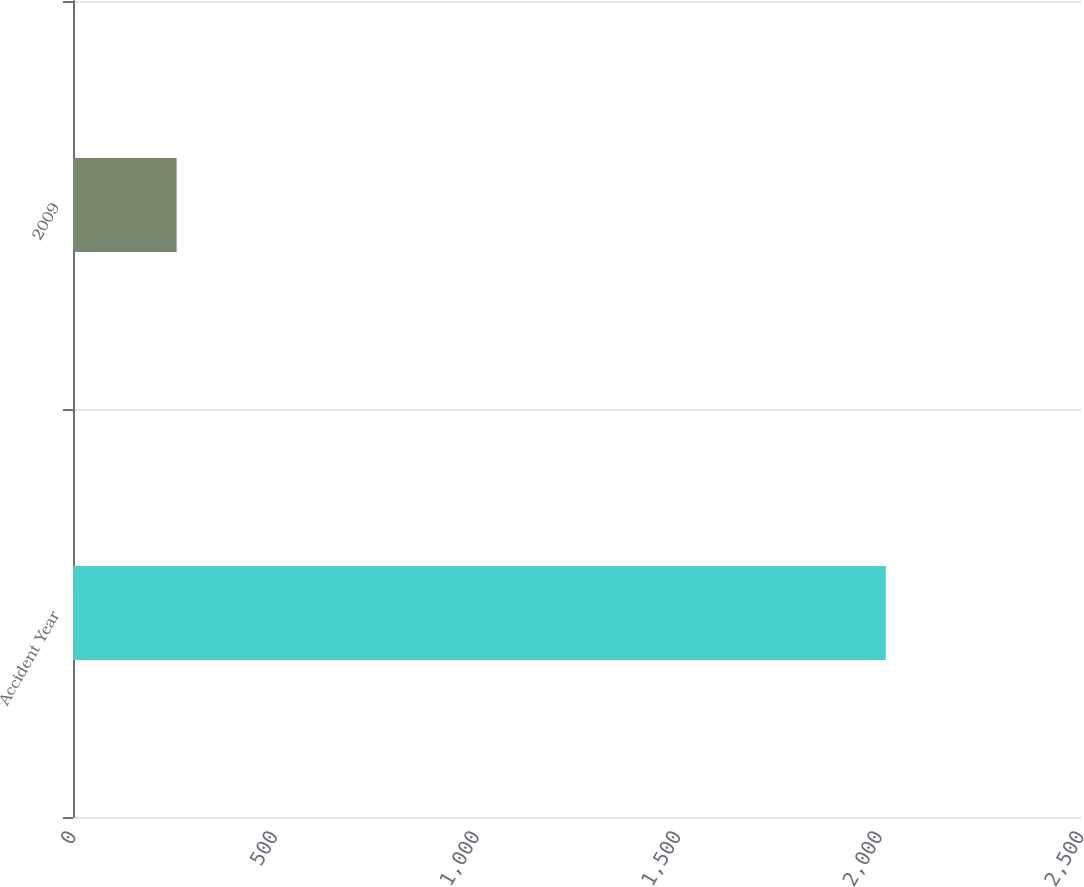Convert chart. <chart><loc_0><loc_0><loc_500><loc_500><bar_chart><fcel>Accident Year<fcel>2009<nl><fcel>2016<fcel>257<nl></chart> 